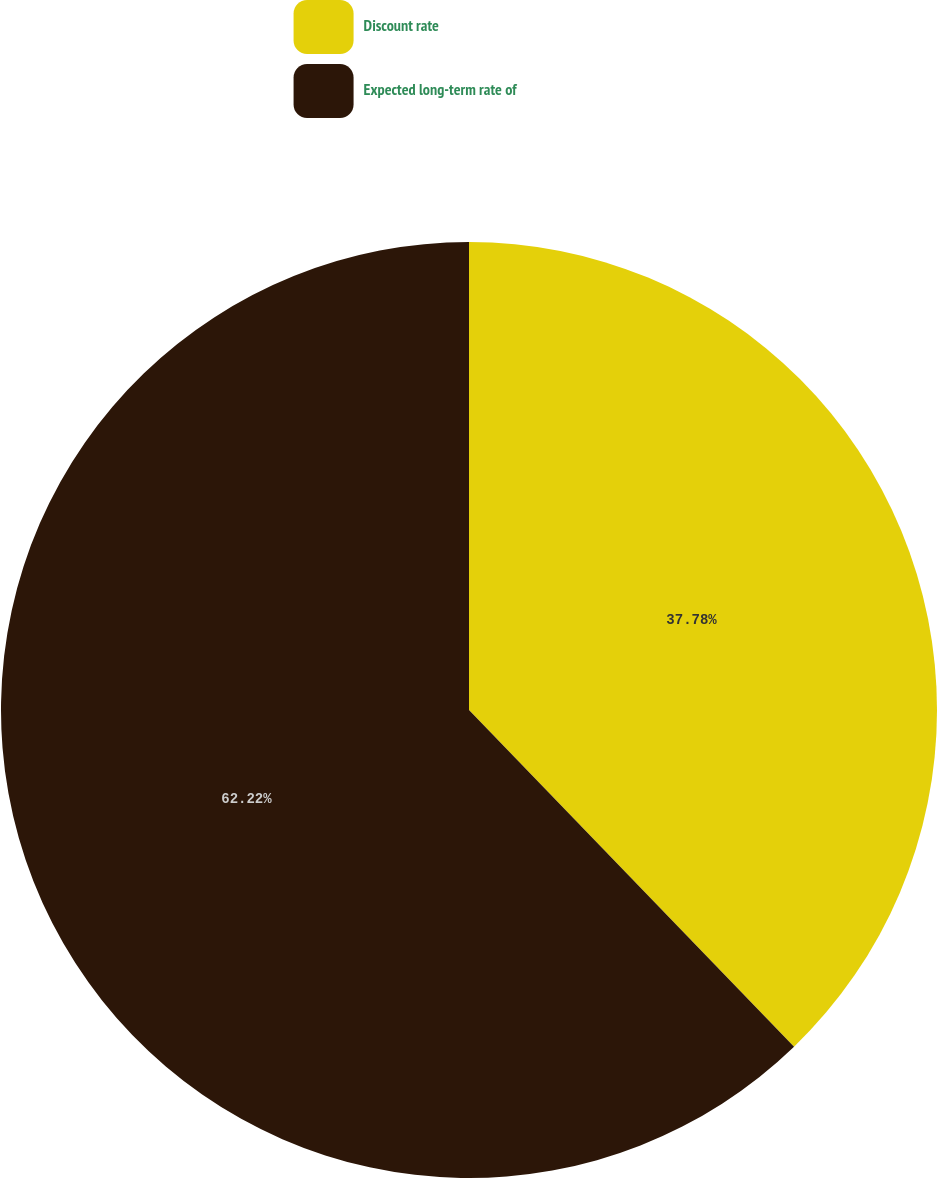<chart> <loc_0><loc_0><loc_500><loc_500><pie_chart><fcel>Discount rate<fcel>Expected long-term rate of<nl><fcel>37.78%<fcel>62.22%<nl></chart> 